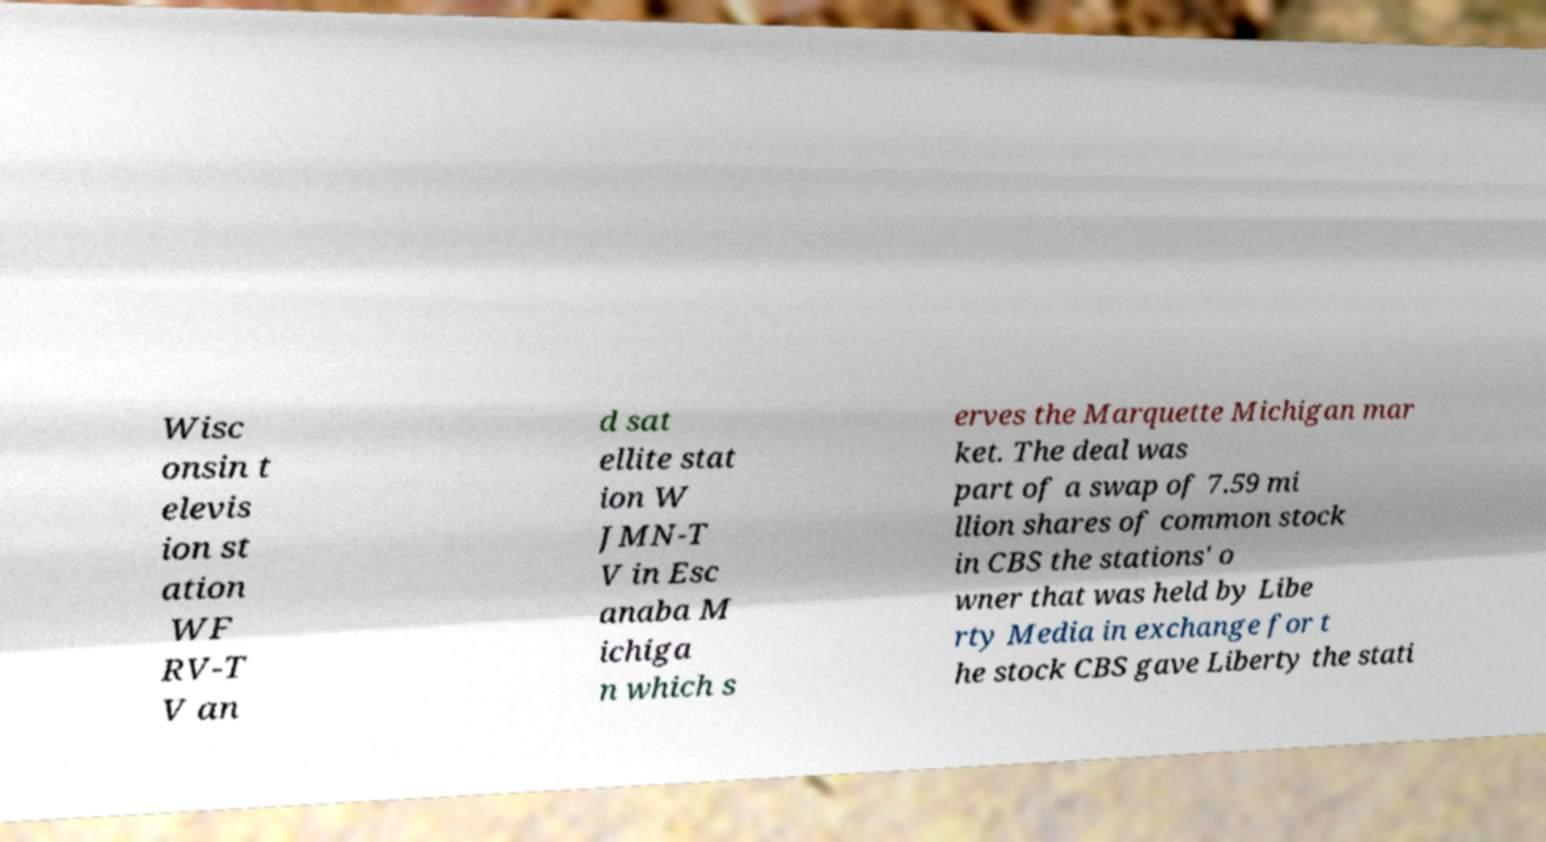Please read and relay the text visible in this image. What does it say? Wisc onsin t elevis ion st ation WF RV-T V an d sat ellite stat ion W JMN-T V in Esc anaba M ichiga n which s erves the Marquette Michigan mar ket. The deal was part of a swap of 7.59 mi llion shares of common stock in CBS the stations' o wner that was held by Libe rty Media in exchange for t he stock CBS gave Liberty the stati 